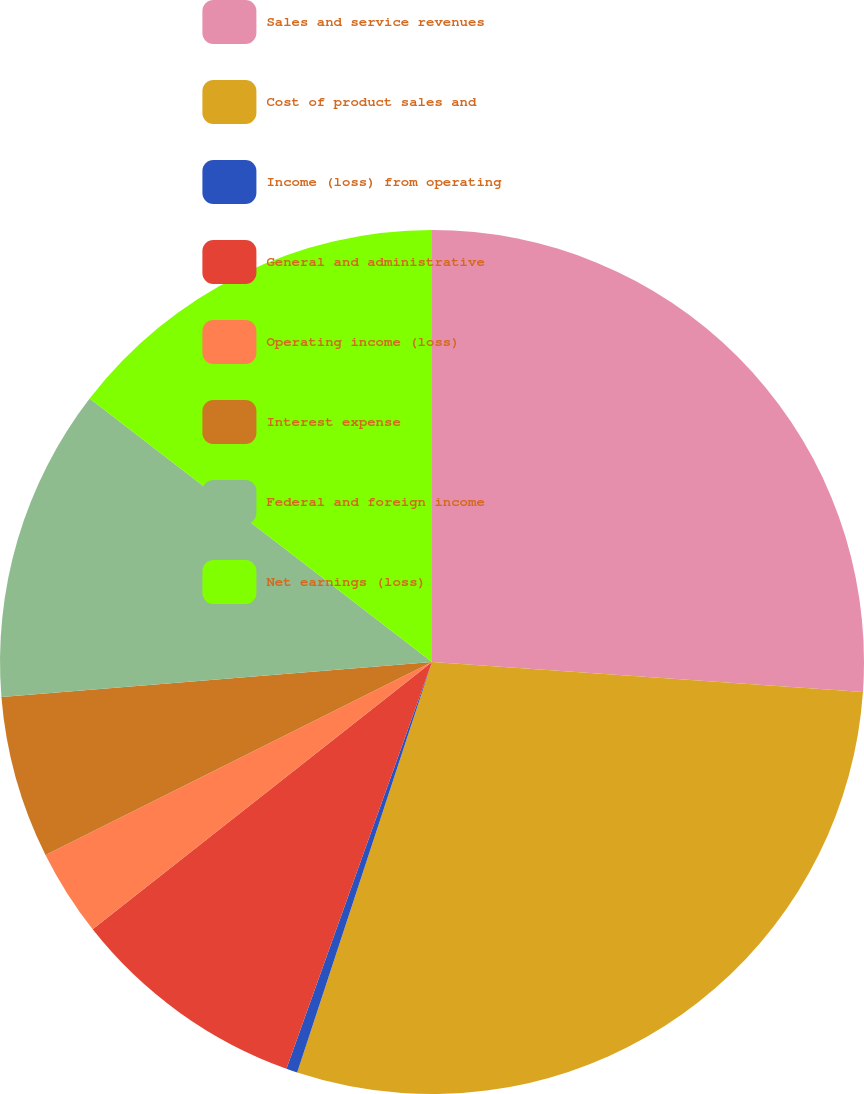Convert chart. <chart><loc_0><loc_0><loc_500><loc_500><pie_chart><fcel>Sales and service revenues<fcel>Cost of product sales and<fcel>Income (loss) from operating<fcel>General and administrative<fcel>Operating income (loss)<fcel>Interest expense<fcel>Federal and foreign income<fcel>Net earnings (loss)<nl><fcel>26.11%<fcel>28.94%<fcel>0.42%<fcel>8.91%<fcel>3.25%<fcel>6.08%<fcel>11.73%<fcel>14.56%<nl></chart> 